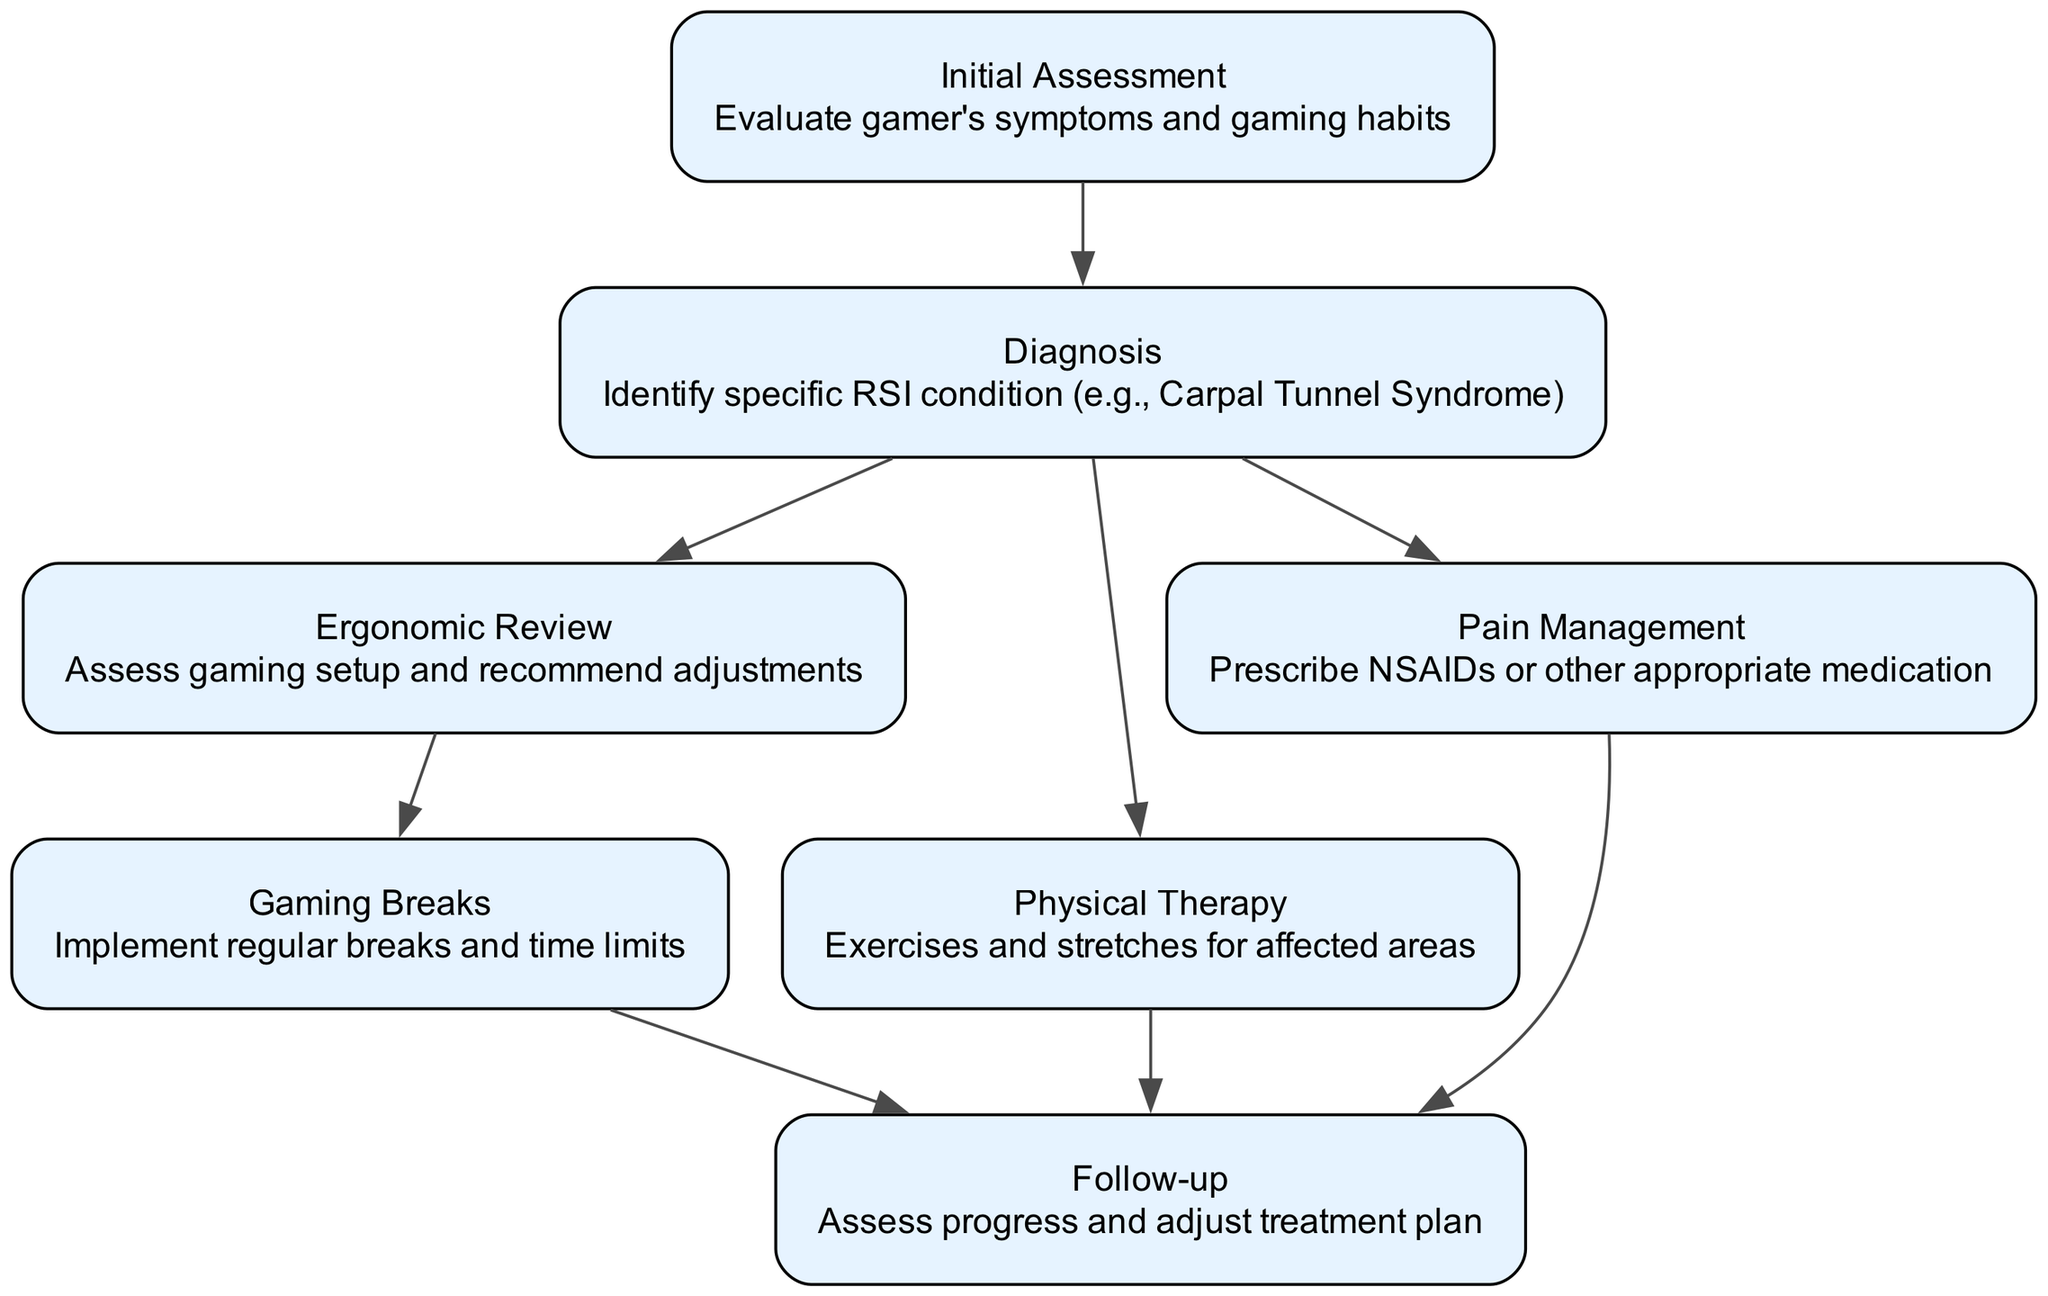What is the first step in the clinical pathway? The first step is labeled as "Initial Assessment," which is indicated as the initial node in the diagram.
Answer: Initial Assessment How many nodes are in the diagram? By counting each unique node labeled in the diagram, we identify that there are a total of seven nodes.
Answer: Seven What condition is identified during the Diagnosis step? The Diagnosis step identifies specific RSI conditions such as Carpal Tunnel Syndrome, which is stated in the description of that node.
Answer: Carpal Tunnel Syndrome Which nodes are connected to the Pain Management node? The Pain Management node has an edge leading to the Follow-up node, indicating a relationship where progress is assessed after pain management.
Answer: Follow-up Which node follows the Physical Therapy step? The Physical Therapy step links to the Follow-up node, which indicates that after engaging in physical therapy, the next step is to assess progress.
Answer: Follow-up What is the purpose of the Gaming Breaks node? The Gaming Breaks node implements regular breaks and time limits, aiming to reduce strain from continuous gaming, as indicated in its description.
Answer: Implement regular breaks In what order do the nodes transition after Diagnosis? After Diagnosis, the flow transitions to Ergonomic Review, Physical Therapy, and Pain Management nodes, which are all connected in sequence.
Answer: Ergonomic Review, Physical Therapy, Pain Management What is the last step in the clinical pathway? The last step in the clinical pathway is the Follow-up node, which assesses progress on all preceding treatments.
Answer: Follow-up How many edges connect the Diagnosis node? The Diagnosis node has three outgoing edges that connect to Ergonomic Review, Physical Therapy, and Pain Management, indicating multiple paths that follow initial diagnosis.
Answer: Three 